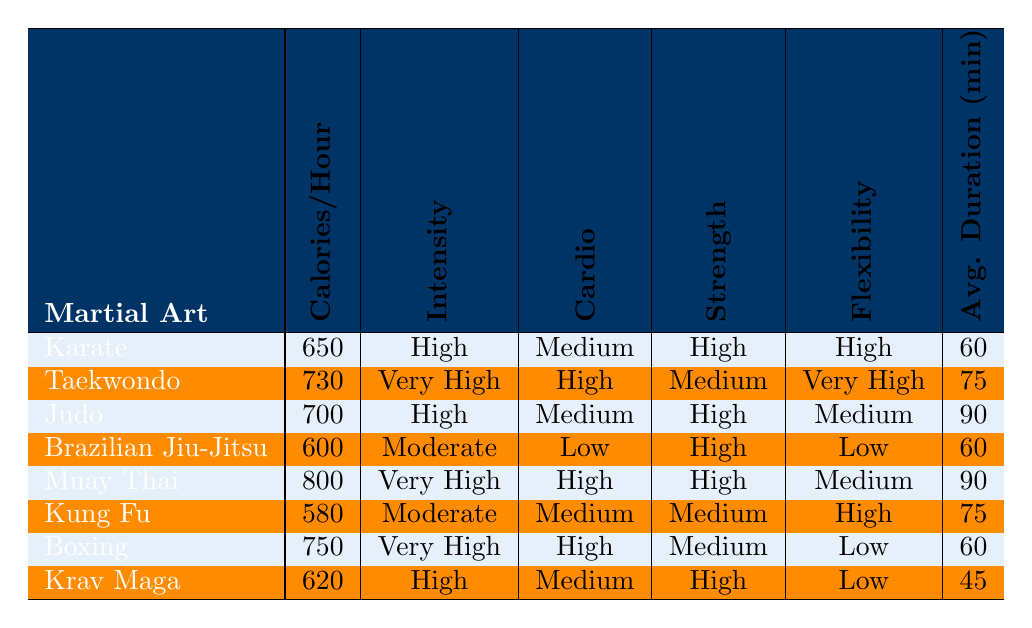What's the martial art with the highest calorie burn rate? The values in the "Calories/Hour" column indicate that Muay Thai has the highest with 800 calories burned per hour.
Answer: Muay Thai Which martial arts styles have a "High" intensity level? By checking the intensity levels in the table, Karate, Judo, Boxing, and Krav Maga are all marked as "High."
Answer: Karate, Judo, Boxing, Krav Maga What is the average calorie burn rate of Karate and Brazilian Jiu-Jitsu combined? Karate burns 650 calories and Brazilian Jiu-Jitsu burns 600 calories. The combined total is 650 + 600 = 1250. Dividing by 2 gives an average of 1250 / 2 = 625 calories per hour.
Answer: 625 Is the cardio emphasis for Taekwondo considered "High"? The table states that Taekwondo has a cardio emphasis labeled as "High."
Answer: Yes Which martial art style has the lowest emphasis on flexibility? By looking at the "Flexibility" column, Kung Fu, Brazilian Jiu-Jitsu, and Krav Maga all have "Low" flexibility emphasis, but Kung Fu has the lowest calorie burn rate.
Answer: Brazilian Jiu-Jitsu and Krav Maga How many martial arts styles are listed with an average training session duration of 75 minutes? The table shows Taekwondo and Kung Fu both have an average training session duration of 75 minutes. Counting them gives a total of 2 styles.
Answer: 2 What is the difference in calories burned per hour between Muay Thai and Kung Fu? Muay Thai burns 800 calories per hour and Kung Fu burns 580 calories per hour. The difference is 800 - 580 = 220 calories.
Answer: 220 Which martial arts style has both "Very High" intensity and "High" cardio emphasis? The table indicates that Taekwondo and Boxing have "Very High" intensity, but only Taekwondo has "High" cardio emphasis while Boxing has "High" cardio emphasis. Therefore, only Taekwondo fits both criteria.
Answer: Taekwondo Are there more styles with a "Moderate" flexibility emphasis than those with a "Medium" flexibility emphasis? The table shows Kung Fu and Brazilian Jiu-Jitsu as "Low" flexibility emphasis while Karate, Judo, and Muay Thai are "High" and all have "Medium," giving a total of 3 of each, so they are equal.
Answer: No What is the average duration of training sessions across all listed martial arts styles? To find the average, we sum the durations (60 + 75 + 90 + 60 + 90 + 75 + 60 + 45 = 525) and divide by the 8 styles. This gives us 525 / 8 = 65.625 minutes.
Answer: 65.625 